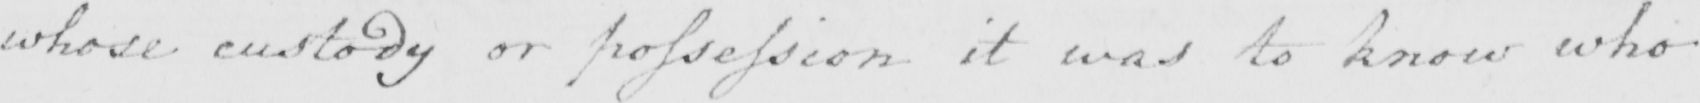What is written in this line of handwriting? whose custody or possession it was to know who 